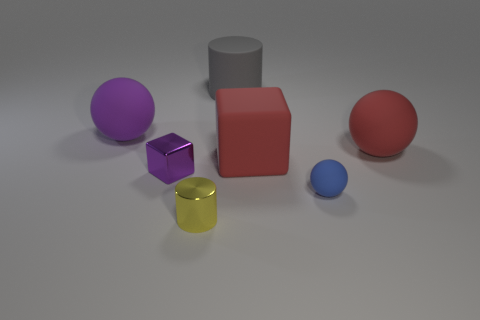Add 1 tiny brown cylinders. How many objects exist? 8 Subtract all big rubber spheres. How many spheres are left? 1 Subtract all gray balls. Subtract all green cylinders. How many balls are left? 3 Subtract all cylinders. How many objects are left? 5 Add 7 small blue matte objects. How many small blue matte objects are left? 8 Add 7 small blue matte things. How many small blue matte things exist? 8 Subtract 0 gray cubes. How many objects are left? 7 Subtract all tiny gray rubber balls. Subtract all tiny objects. How many objects are left? 4 